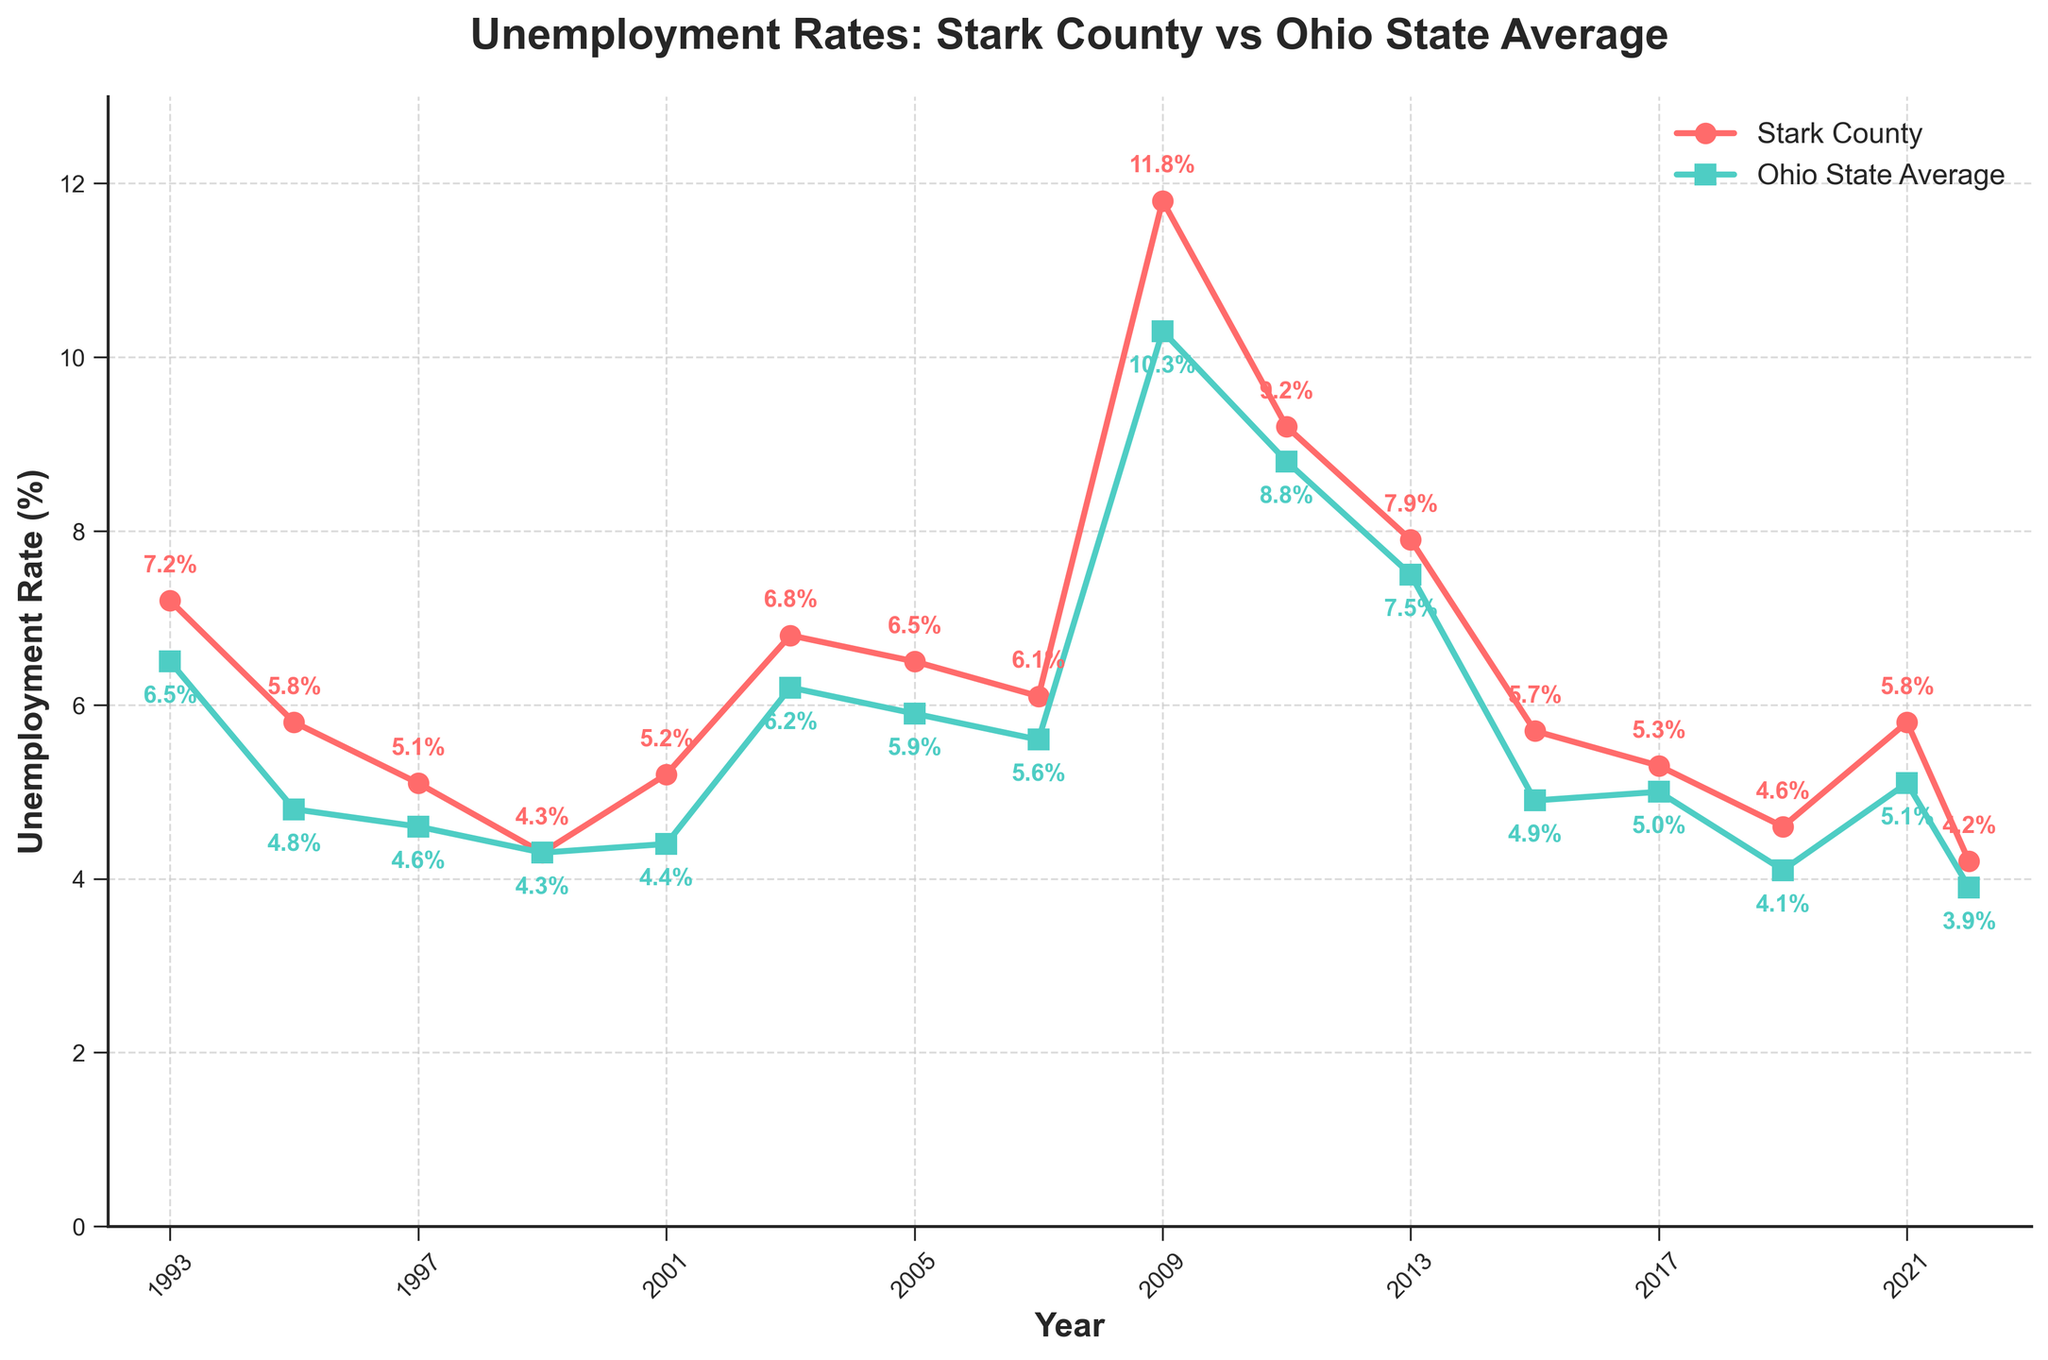What was Stark County's highest unemployment rate in the given period? Look for Stark County's highest point on the plot marked with 'o' markers. The highest point occurs in 2009 at 11.8%.
Answer: 11.8% Was Stark County's unemployment rate ever below the Ohio state average during this period? Compare the Stark County line and Ohio line. At every point where Stark County's line is above or touching Ohio's line. Stark County's unemployment rate was never below Ohio's.
Answer: No Which year had the smallest difference between Stark County and Ohio's unemployment rates? Calculate the differences for each year by subtracting Ohio's rates from Stark County's rates, then find the minimum difference. In 1999, both rates were equal at 4.3%, so the difference is 0.
Answer: 1999 In which year did Stark County have the sharpest increase in unemployment rate compared to the previous year? Find the year where the difference between consecutive year's rates for Stark County is the largest. From 2007 to 2009, there was an increase from 6.1% to 11.8%, a 5.7% jump.
Answer: 2009 Between 2011 and 2013, did Stark County's unemployment rate decrease faster than Ohio's state average? Calculate the rate of decrease (% decrease) for both Stark County and Ohio from 2011 to 2013. Stark County: ((9.2% - 7.9%) / 9.2%) * 100 ≈ 14.13%, Ohio: ((8.8% - 7.5%) / 8.8%) * 100 ≈ 14.77%. Compare the percentages to determine which is greater.
Answer: No What is the average unemployment rate of Stark County over the given period? Sum the unemployment rates of Stark County and divide by the number of years (16 years). The sum is 101.5. So, 101.5 / 16 = 6.34.
Answer: 6.3% In which year does Stark County's unemployment rate return to pre-2009 economic crisis levels (below 6%)? Look for the first year after 2009 where Stark County's unemployment rate drops below 6%. Stark County drops below 6% in 2015.
Answer: 2015 How many times did Stark County's unemployment rate increase consecutively within the given period? Identify the periods where the rate increases year-over-year. Between 1993 to 1997, 2001 to 2003, 2005 to 2009, and 2019 to 2021, increases occur. Count these periods.
Answer: 4 times When comparing only 2017 and 2022, did Stark County's unemployment rate decrease more significantly than Ohio's state average? Calculate the decrease for both regions from 2017 to 2022. Stark County: 5.3% - 4.2% = 1.1%, Ohio State: 5% - 3.9% = 1.1%. Compare these values.
Answer: No During which period did both regions experience an overall decline in unemployment rates for at least three consecutive years? Identify periods where both lines consistently go downward for three or more consecutive years. From 2013 to 2019, both regions show a decline.
Answer: 2013-2019 